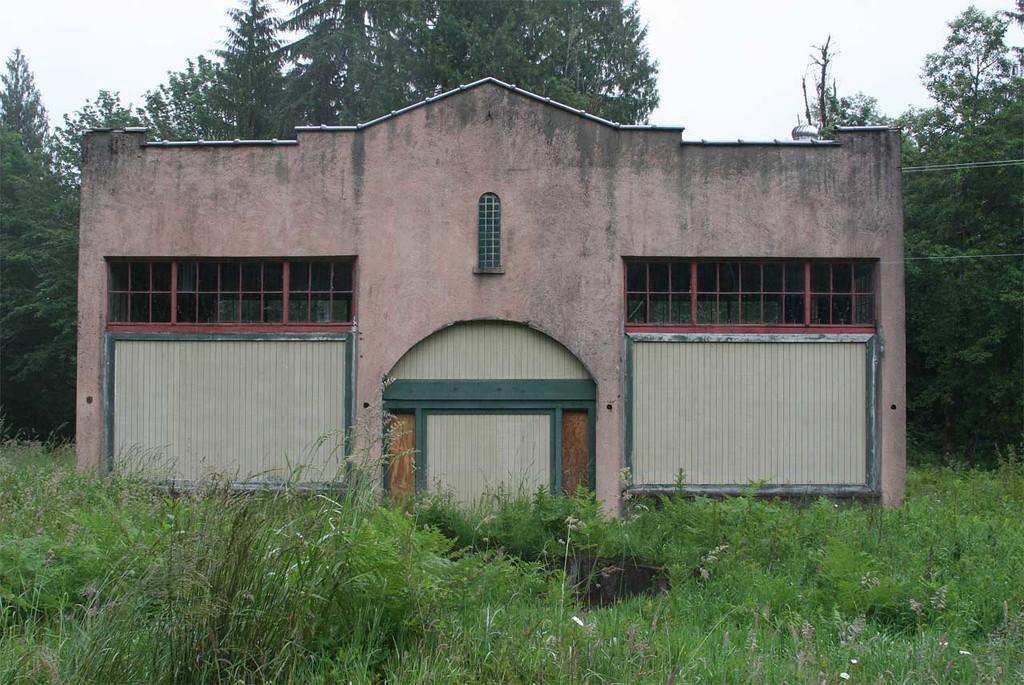How would you summarize this image in a sentence or two? In the center of the image there is a building. At the bottom there is a grass and plants. In the background there are trees and sky. 